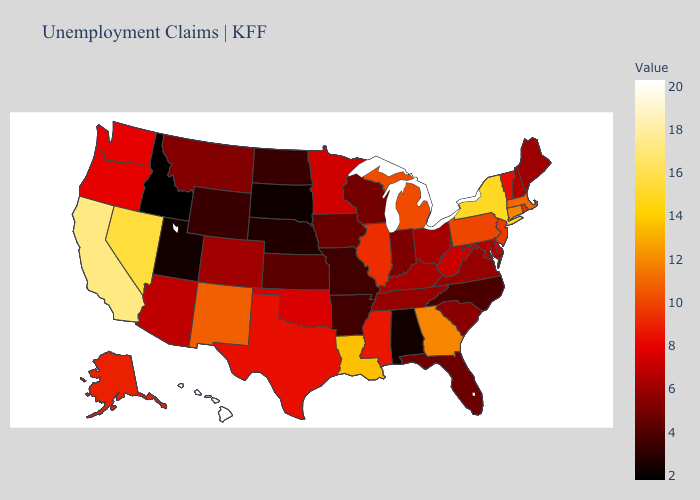Does Louisiana have a higher value than Kentucky?
Give a very brief answer. Yes. Which states have the lowest value in the Northeast?
Answer briefly. Maine. Does Hawaii have the highest value in the USA?
Be succinct. Yes. 